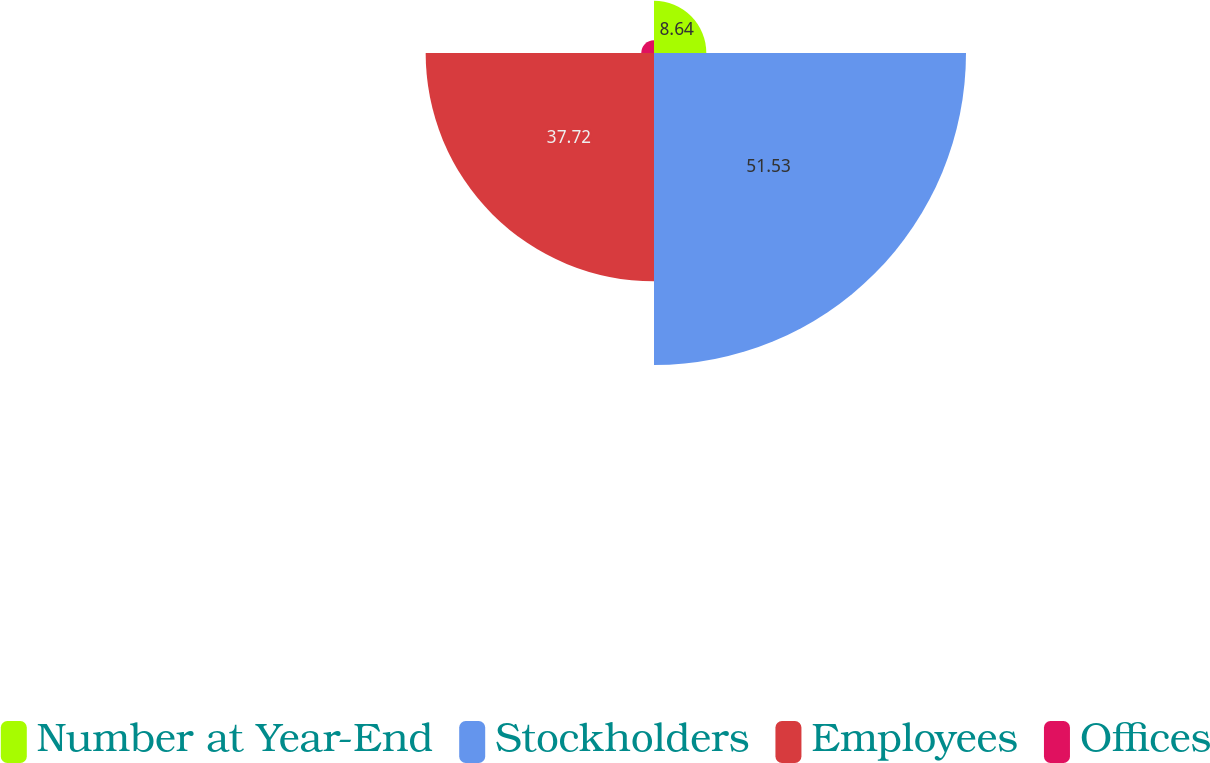Convert chart. <chart><loc_0><loc_0><loc_500><loc_500><pie_chart><fcel>Number at Year-End<fcel>Stockholders<fcel>Employees<fcel>Offices<nl><fcel>8.64%<fcel>51.54%<fcel>37.72%<fcel>2.11%<nl></chart> 